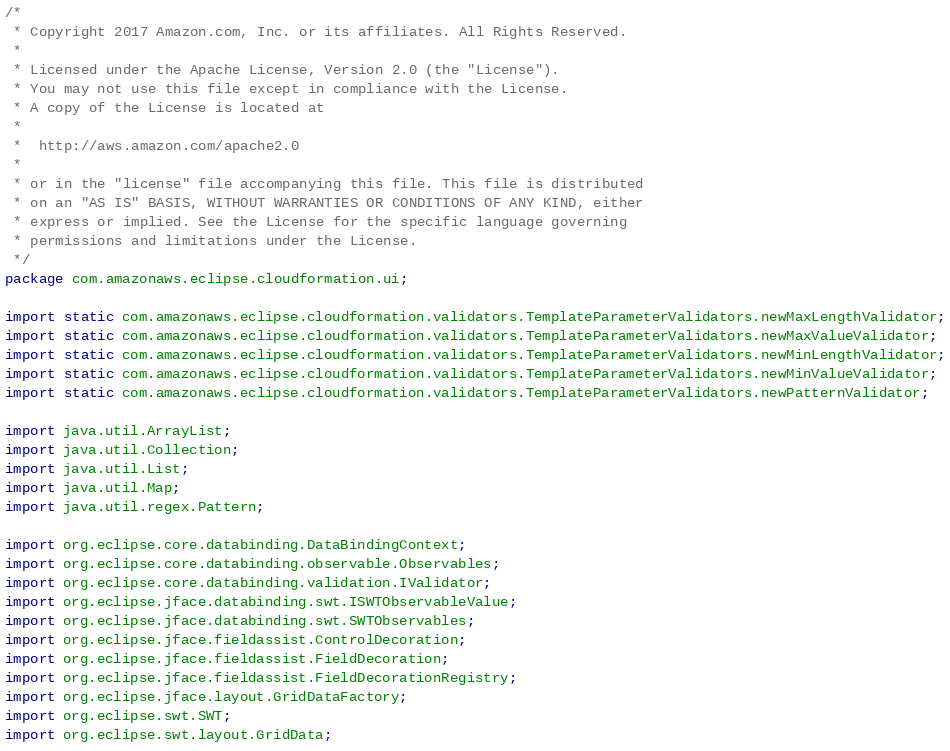Convert code to text. <code><loc_0><loc_0><loc_500><loc_500><_Java_>/*
 * Copyright 2017 Amazon.com, Inc. or its affiliates. All Rights Reserved.
 *
 * Licensed under the Apache License, Version 2.0 (the "License").
 * You may not use this file except in compliance with the License.
 * A copy of the License is located at
 *
 *  http://aws.amazon.com/apache2.0
 *
 * or in the "license" file accompanying this file. This file is distributed
 * on an "AS IS" BASIS, WITHOUT WARRANTIES OR CONDITIONS OF ANY KIND, either
 * express or implied. See the License for the specific language governing
 * permissions and limitations under the License.
 */
package com.amazonaws.eclipse.cloudformation.ui;

import static com.amazonaws.eclipse.cloudformation.validators.TemplateParameterValidators.newMaxLengthValidator;
import static com.amazonaws.eclipse.cloudformation.validators.TemplateParameterValidators.newMaxValueValidator;
import static com.amazonaws.eclipse.cloudformation.validators.TemplateParameterValidators.newMinLengthValidator;
import static com.amazonaws.eclipse.cloudformation.validators.TemplateParameterValidators.newMinValueValidator;
import static com.amazonaws.eclipse.cloudformation.validators.TemplateParameterValidators.newPatternValidator;

import java.util.ArrayList;
import java.util.Collection;
import java.util.List;
import java.util.Map;
import java.util.regex.Pattern;

import org.eclipse.core.databinding.DataBindingContext;
import org.eclipse.core.databinding.observable.Observables;
import org.eclipse.core.databinding.validation.IValidator;
import org.eclipse.jface.databinding.swt.ISWTObservableValue;
import org.eclipse.jface.databinding.swt.SWTObservables;
import org.eclipse.jface.fieldassist.ControlDecoration;
import org.eclipse.jface.fieldassist.FieldDecoration;
import org.eclipse.jface.fieldassist.FieldDecorationRegistry;
import org.eclipse.jface.layout.GridDataFactory;
import org.eclipse.swt.SWT;
import org.eclipse.swt.layout.GridData;</code> 